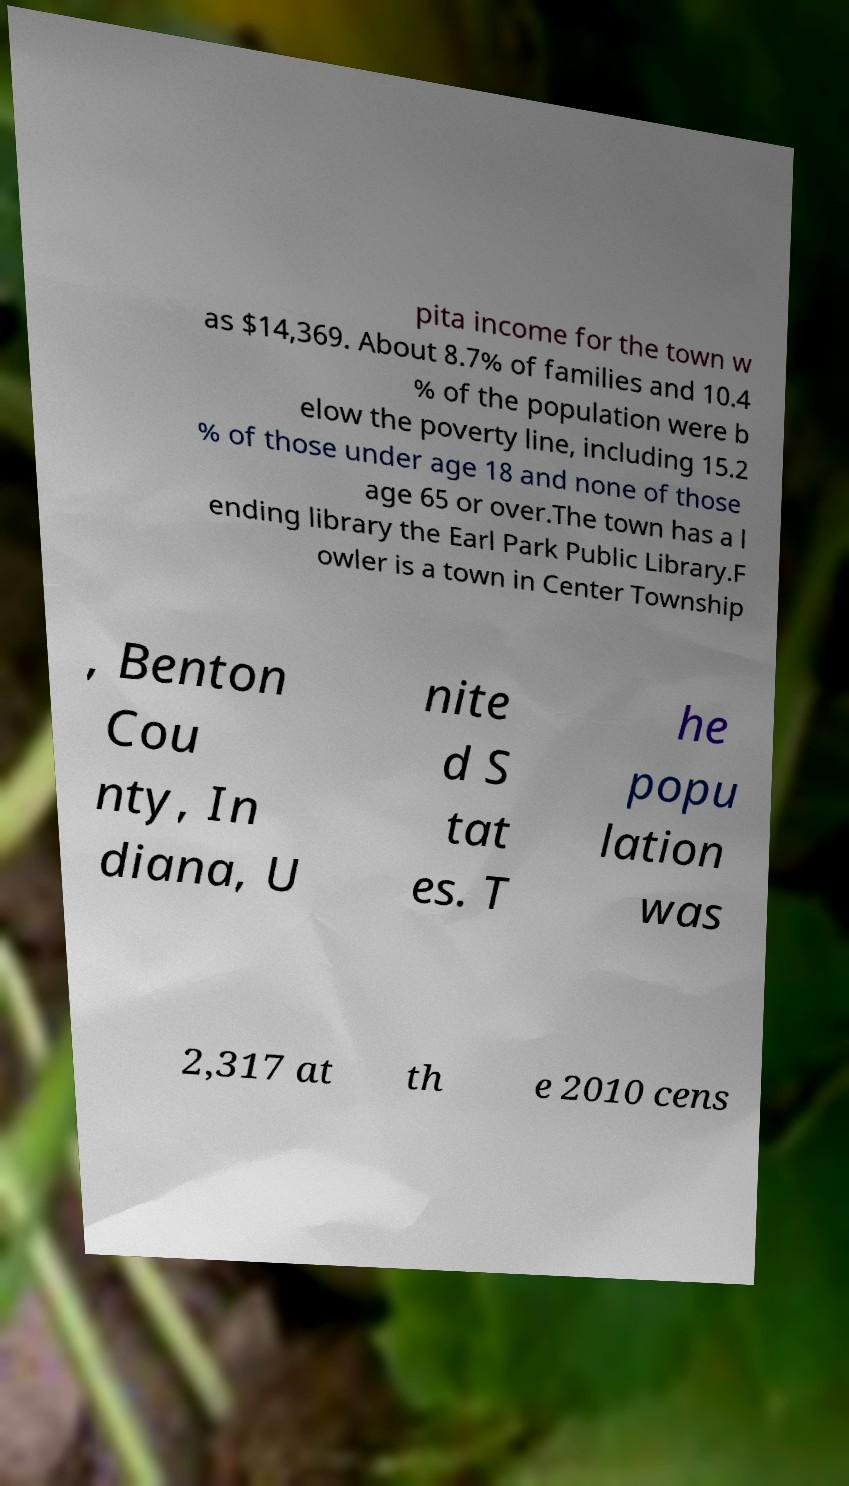Could you assist in decoding the text presented in this image and type it out clearly? pita income for the town w as $14,369. About 8.7% of families and 10.4 % of the population were b elow the poverty line, including 15.2 % of those under age 18 and none of those age 65 or over.The town has a l ending library the Earl Park Public Library.F owler is a town in Center Township , Benton Cou nty, In diana, U nite d S tat es. T he popu lation was 2,317 at th e 2010 cens 